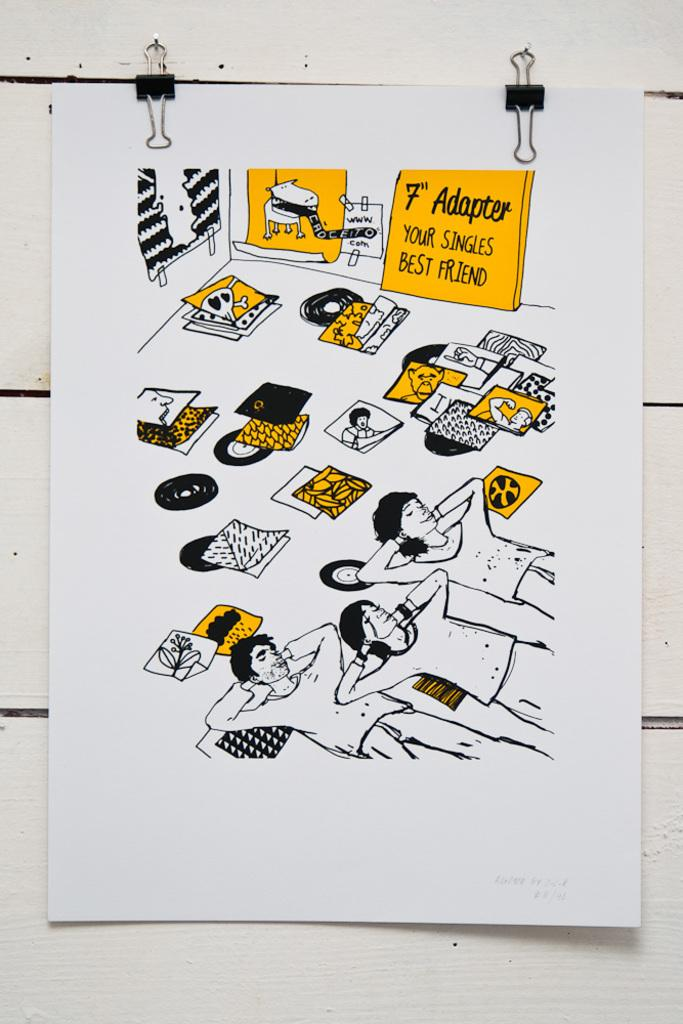<image>
Create a compact narrative representing the image presented. A card is hung up that shows a drawing of 3 people laying on the ground, with a hand drawn sign that says "7" adapter your singles best friend". 